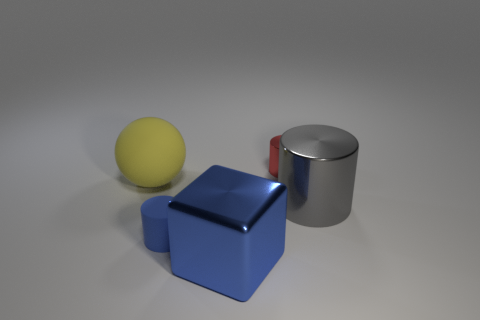Subtract all shiny cylinders. How many cylinders are left? 1 Subtract all red blocks. How many red cylinders are left? 1 Add 2 big yellow objects. How many objects exist? 7 Subtract all blue cylinders. How many cylinders are left? 2 Subtract 0 green blocks. How many objects are left? 5 Subtract all blocks. How many objects are left? 4 Subtract all blue cylinders. Subtract all yellow balls. How many cylinders are left? 2 Subtract all green shiny cylinders. Subtract all gray metallic things. How many objects are left? 4 Add 2 gray metallic cylinders. How many gray metallic cylinders are left? 3 Add 5 big yellow spheres. How many big yellow spheres exist? 6 